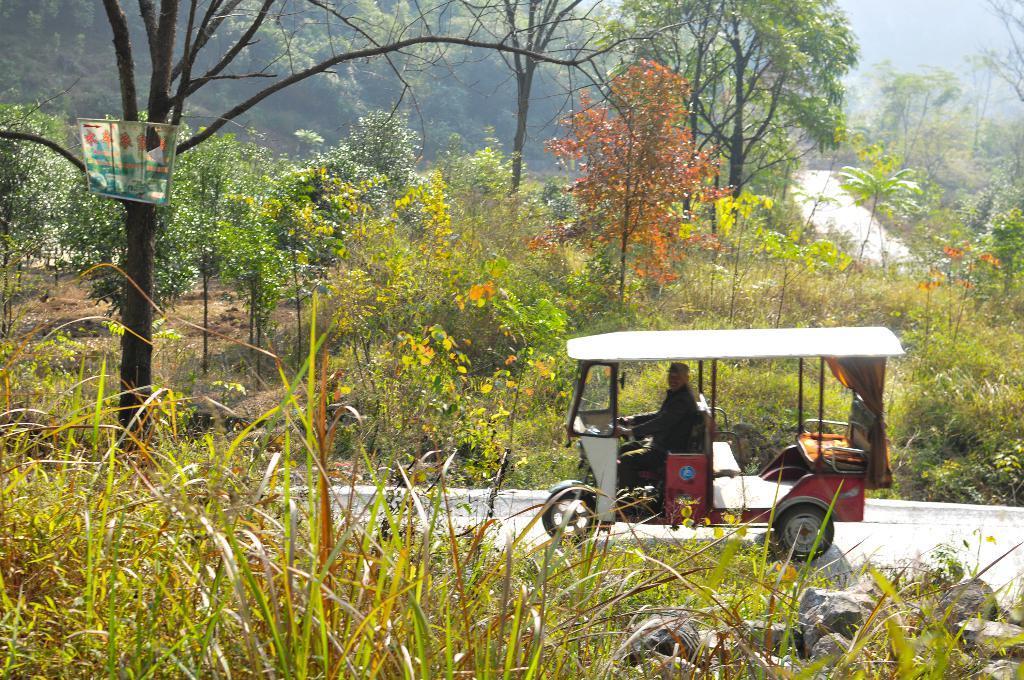In one or two sentences, can you explain what this image depicts? In this image I can see person riding vehicle on the road, beside that there are so many plants, trees and mountains at the back. 